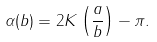Convert formula to latex. <formula><loc_0><loc_0><loc_500><loc_500>\alpha ( b ) = 2 K \left ( \frac { a } { b } \right ) - \pi .</formula> 